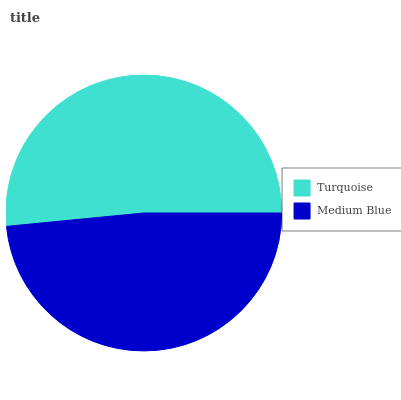Is Medium Blue the minimum?
Answer yes or no. Yes. Is Turquoise the maximum?
Answer yes or no. Yes. Is Medium Blue the maximum?
Answer yes or no. No. Is Turquoise greater than Medium Blue?
Answer yes or no. Yes. Is Medium Blue less than Turquoise?
Answer yes or no. Yes. Is Medium Blue greater than Turquoise?
Answer yes or no. No. Is Turquoise less than Medium Blue?
Answer yes or no. No. Is Turquoise the high median?
Answer yes or no. Yes. Is Medium Blue the low median?
Answer yes or no. Yes. Is Medium Blue the high median?
Answer yes or no. No. Is Turquoise the low median?
Answer yes or no. No. 